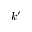Convert formula to latex. <formula><loc_0><loc_0><loc_500><loc_500>k ^ { \prime }</formula> 